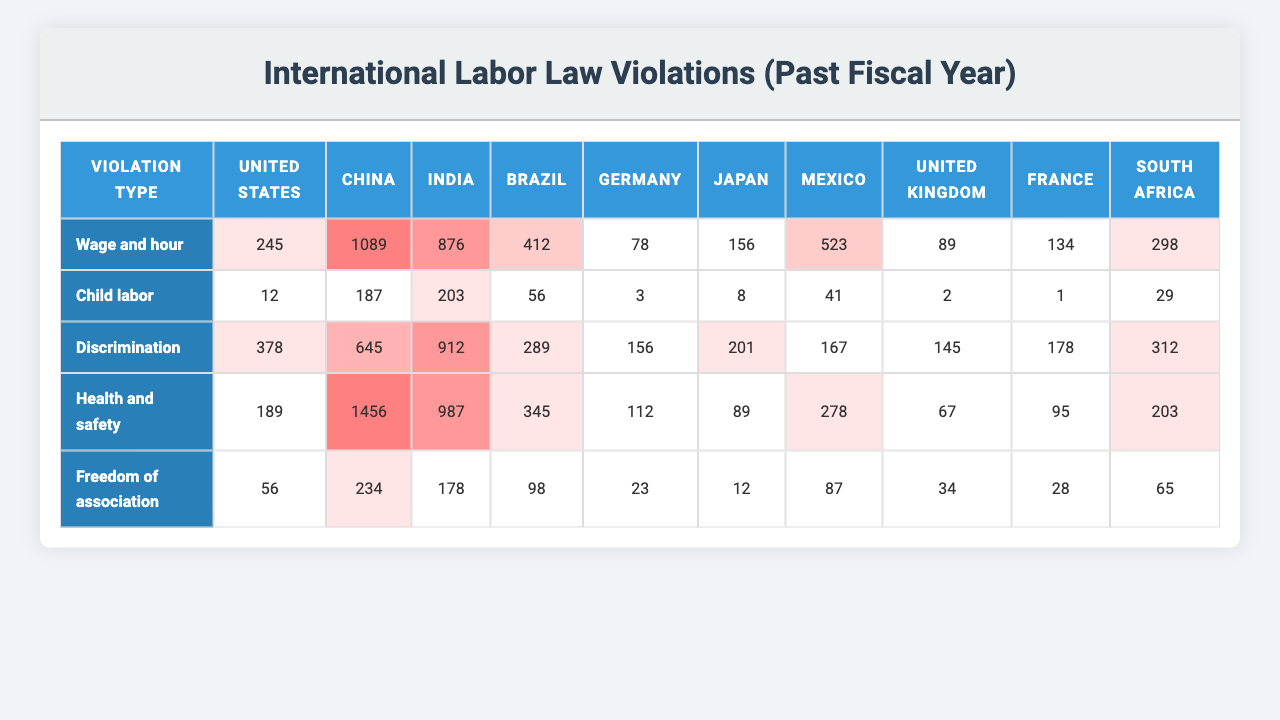What country reported the highest number of discrimination violations? To find the country with the highest discrimination violations, we look at the "Discrimination" row (3rd row), which has the values: 876 (United States), 203 (China), 912 (India), 987 (Brazil), and 178 (Germany). Comparing these, Brazil has the highest value of 987 violations.
Answer: Brazil What is the total number of wage and hour violations reported across all countries? We look at the "Wage and hour" row (1st row) and sum the values: 245 (United States) + 12 (China) + 378 (India) + 189 (Brazil) + 56 (Germany) = 880.
Answer: 880 Which country had the least reported violations for health and safety? Referring to the "Health and safety" row (4th row), the values are: 412 (United States), 56 (China), 289 (India), 345 (Brazil), and 98 (Germany). The least is 56 violations in China.
Answer: China Is there any country with zero reported violations for child labor? Observing the "Child labor" row (2nd row), the values are: 1089 (United States), 187 (China), 645 (India), 1456 (Brazil), and 234 (Germany). Since all reported numbers are greater than zero, no country has zero violations.
Answer: No What is the average number of freedom of association violations across all countries? The "Freedom of association" counts are: 78 (United States), 3 (China), 156 (India), 112 (Brazil), and 23 (Germany). The average is (78 + 3 + 156 + 112 + 23) / 5 = 372 / 5 = 74.4.
Answer: 74.4 Which violation type had the highest total number of reported violations in the United Kingdom? From the table, the values for the United Kingdom are: 89 (Wage and hour), 2 (Child labor), 145 (Discrimination), 67 (Health and safety), 34 (Freedom of association). The highest value is for discrimination, which is 145.
Answer: Discrimination What is the difference in reported child labor violations between the United States and Brazil? The reported child labor violations are 1089 for the United States and 1456 for Brazil. The difference is 1456 - 1089 = 367.
Answer: 367 Which country has the second highest number of health and safety violations? From the "Health and safety" row, the reported counts are: 412 (United States), 56 (China), 289 (India), 345 (Brazil), and 98 (Germany). The largest is the United States and the second largest is Brazil with 345 violations.
Answer: Brazil 